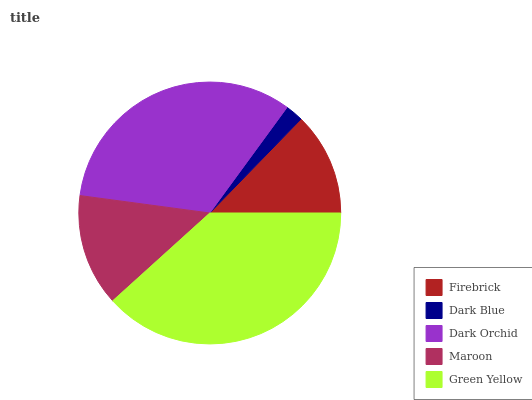Is Dark Blue the minimum?
Answer yes or no. Yes. Is Green Yellow the maximum?
Answer yes or no. Yes. Is Dark Orchid the minimum?
Answer yes or no. No. Is Dark Orchid the maximum?
Answer yes or no. No. Is Dark Orchid greater than Dark Blue?
Answer yes or no. Yes. Is Dark Blue less than Dark Orchid?
Answer yes or no. Yes. Is Dark Blue greater than Dark Orchid?
Answer yes or no. No. Is Dark Orchid less than Dark Blue?
Answer yes or no. No. Is Maroon the high median?
Answer yes or no. Yes. Is Maroon the low median?
Answer yes or no. Yes. Is Green Yellow the high median?
Answer yes or no. No. Is Dark Orchid the low median?
Answer yes or no. No. 